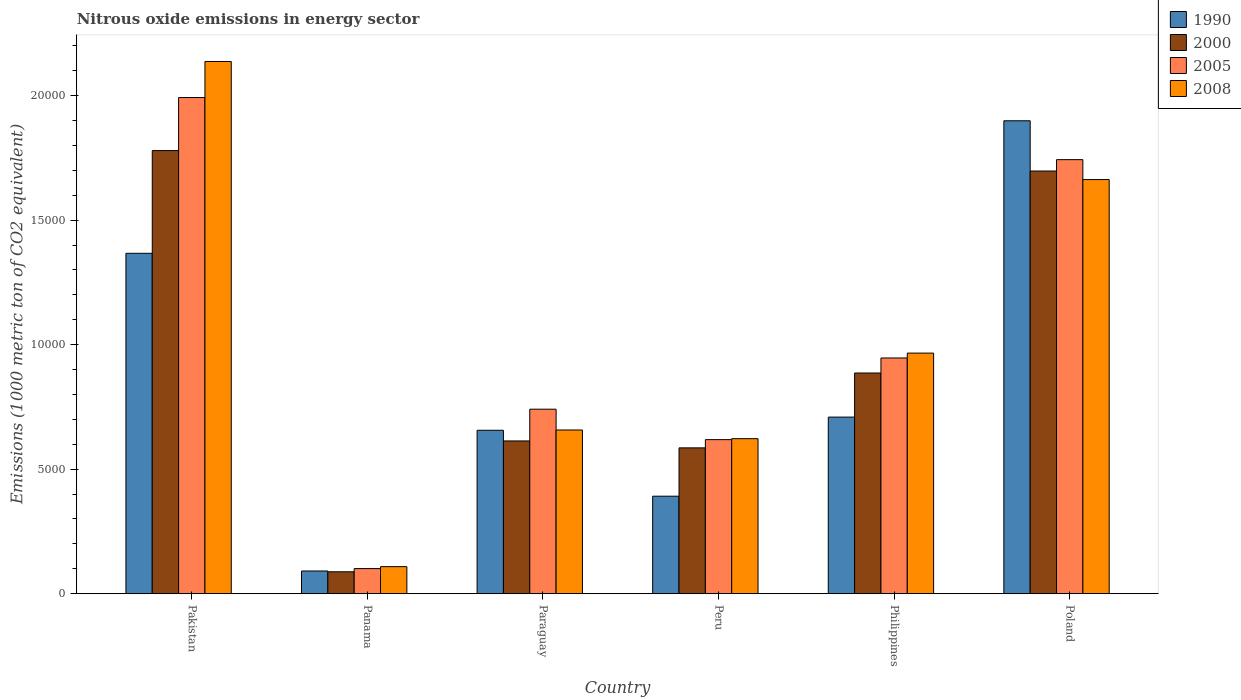How many different coloured bars are there?
Provide a short and direct response. 4. Are the number of bars per tick equal to the number of legend labels?
Your response must be concise. Yes. Are the number of bars on each tick of the X-axis equal?
Provide a succinct answer. Yes. How many bars are there on the 2nd tick from the left?
Your response must be concise. 4. What is the label of the 2nd group of bars from the left?
Offer a terse response. Panama. What is the amount of nitrous oxide emitted in 2008 in Paraguay?
Provide a short and direct response. 6573. Across all countries, what is the maximum amount of nitrous oxide emitted in 2000?
Keep it short and to the point. 1.78e+04. Across all countries, what is the minimum amount of nitrous oxide emitted in 1990?
Your answer should be very brief. 910.4. In which country was the amount of nitrous oxide emitted in 1990 minimum?
Give a very brief answer. Panama. What is the total amount of nitrous oxide emitted in 2005 in the graph?
Your response must be concise. 6.14e+04. What is the difference between the amount of nitrous oxide emitted in 2008 in Panama and that in Philippines?
Provide a succinct answer. -8575.9. What is the difference between the amount of nitrous oxide emitted in 2008 in Paraguay and the amount of nitrous oxide emitted in 2005 in Peru?
Your answer should be compact. 387.2. What is the average amount of nitrous oxide emitted in 2005 per country?
Ensure brevity in your answer.  1.02e+04. What is the difference between the amount of nitrous oxide emitted of/in 2000 and amount of nitrous oxide emitted of/in 2005 in Poland?
Make the answer very short. -457.1. What is the ratio of the amount of nitrous oxide emitted in 2000 in Pakistan to that in Paraguay?
Your answer should be very brief. 2.9. Is the amount of nitrous oxide emitted in 2008 in Peru less than that in Philippines?
Give a very brief answer. Yes. Is the difference between the amount of nitrous oxide emitted in 2000 in Peru and Philippines greater than the difference between the amount of nitrous oxide emitted in 2005 in Peru and Philippines?
Keep it short and to the point. Yes. What is the difference between the highest and the second highest amount of nitrous oxide emitted in 2005?
Offer a terse response. -1.05e+04. What is the difference between the highest and the lowest amount of nitrous oxide emitted in 2008?
Make the answer very short. 2.03e+04. Is it the case that in every country, the sum of the amount of nitrous oxide emitted in 1990 and amount of nitrous oxide emitted in 2005 is greater than the sum of amount of nitrous oxide emitted in 2000 and amount of nitrous oxide emitted in 2008?
Provide a succinct answer. No. What does the 2nd bar from the left in Panama represents?
Your response must be concise. 2000. What does the 1st bar from the right in Pakistan represents?
Offer a terse response. 2008. Is it the case that in every country, the sum of the amount of nitrous oxide emitted in 2005 and amount of nitrous oxide emitted in 2000 is greater than the amount of nitrous oxide emitted in 2008?
Your answer should be compact. Yes. What is the difference between two consecutive major ticks on the Y-axis?
Keep it short and to the point. 5000. Does the graph contain grids?
Provide a short and direct response. No. Where does the legend appear in the graph?
Your response must be concise. Top right. How many legend labels are there?
Ensure brevity in your answer.  4. How are the legend labels stacked?
Offer a very short reply. Vertical. What is the title of the graph?
Your answer should be compact. Nitrous oxide emissions in energy sector. Does "1994" appear as one of the legend labels in the graph?
Make the answer very short. No. What is the label or title of the Y-axis?
Provide a succinct answer. Emissions (1000 metric ton of CO2 equivalent). What is the Emissions (1000 metric ton of CO2 equivalent) of 1990 in Pakistan?
Give a very brief answer. 1.37e+04. What is the Emissions (1000 metric ton of CO2 equivalent) in 2000 in Pakistan?
Offer a terse response. 1.78e+04. What is the Emissions (1000 metric ton of CO2 equivalent) of 2005 in Pakistan?
Ensure brevity in your answer.  1.99e+04. What is the Emissions (1000 metric ton of CO2 equivalent) in 2008 in Pakistan?
Offer a terse response. 2.14e+04. What is the Emissions (1000 metric ton of CO2 equivalent) in 1990 in Panama?
Offer a terse response. 910.4. What is the Emissions (1000 metric ton of CO2 equivalent) of 2000 in Panama?
Provide a short and direct response. 878.4. What is the Emissions (1000 metric ton of CO2 equivalent) of 2005 in Panama?
Make the answer very short. 1006.8. What is the Emissions (1000 metric ton of CO2 equivalent) of 2008 in Panama?
Your answer should be compact. 1084.9. What is the Emissions (1000 metric ton of CO2 equivalent) in 1990 in Paraguay?
Ensure brevity in your answer.  6561.2. What is the Emissions (1000 metric ton of CO2 equivalent) of 2000 in Paraguay?
Offer a very short reply. 6132.8. What is the Emissions (1000 metric ton of CO2 equivalent) in 2005 in Paraguay?
Ensure brevity in your answer.  7407.7. What is the Emissions (1000 metric ton of CO2 equivalent) in 2008 in Paraguay?
Ensure brevity in your answer.  6573. What is the Emissions (1000 metric ton of CO2 equivalent) of 1990 in Peru?
Make the answer very short. 3914.1. What is the Emissions (1000 metric ton of CO2 equivalent) in 2000 in Peru?
Offer a terse response. 5854.9. What is the Emissions (1000 metric ton of CO2 equivalent) of 2005 in Peru?
Your answer should be very brief. 6185.8. What is the Emissions (1000 metric ton of CO2 equivalent) of 2008 in Peru?
Provide a succinct answer. 6224.5. What is the Emissions (1000 metric ton of CO2 equivalent) of 1990 in Philippines?
Your response must be concise. 7090.2. What is the Emissions (1000 metric ton of CO2 equivalent) in 2000 in Philippines?
Your answer should be very brief. 8861.1. What is the Emissions (1000 metric ton of CO2 equivalent) of 2005 in Philippines?
Give a very brief answer. 9465.1. What is the Emissions (1000 metric ton of CO2 equivalent) of 2008 in Philippines?
Offer a terse response. 9660.8. What is the Emissions (1000 metric ton of CO2 equivalent) of 1990 in Poland?
Give a very brief answer. 1.90e+04. What is the Emissions (1000 metric ton of CO2 equivalent) in 2000 in Poland?
Offer a very short reply. 1.70e+04. What is the Emissions (1000 metric ton of CO2 equivalent) in 2005 in Poland?
Your response must be concise. 1.74e+04. What is the Emissions (1000 metric ton of CO2 equivalent) of 2008 in Poland?
Provide a succinct answer. 1.66e+04. Across all countries, what is the maximum Emissions (1000 metric ton of CO2 equivalent) in 1990?
Provide a succinct answer. 1.90e+04. Across all countries, what is the maximum Emissions (1000 metric ton of CO2 equivalent) in 2000?
Offer a very short reply. 1.78e+04. Across all countries, what is the maximum Emissions (1000 metric ton of CO2 equivalent) in 2005?
Offer a very short reply. 1.99e+04. Across all countries, what is the maximum Emissions (1000 metric ton of CO2 equivalent) of 2008?
Keep it short and to the point. 2.14e+04. Across all countries, what is the minimum Emissions (1000 metric ton of CO2 equivalent) of 1990?
Give a very brief answer. 910.4. Across all countries, what is the minimum Emissions (1000 metric ton of CO2 equivalent) of 2000?
Offer a terse response. 878.4. Across all countries, what is the minimum Emissions (1000 metric ton of CO2 equivalent) of 2005?
Ensure brevity in your answer.  1006.8. Across all countries, what is the minimum Emissions (1000 metric ton of CO2 equivalent) of 2008?
Offer a very short reply. 1084.9. What is the total Emissions (1000 metric ton of CO2 equivalent) of 1990 in the graph?
Make the answer very short. 5.11e+04. What is the total Emissions (1000 metric ton of CO2 equivalent) of 2000 in the graph?
Your answer should be very brief. 5.65e+04. What is the total Emissions (1000 metric ton of CO2 equivalent) of 2005 in the graph?
Your response must be concise. 6.14e+04. What is the total Emissions (1000 metric ton of CO2 equivalent) in 2008 in the graph?
Offer a terse response. 6.15e+04. What is the difference between the Emissions (1000 metric ton of CO2 equivalent) of 1990 in Pakistan and that in Panama?
Make the answer very short. 1.28e+04. What is the difference between the Emissions (1000 metric ton of CO2 equivalent) of 2000 in Pakistan and that in Panama?
Ensure brevity in your answer.  1.69e+04. What is the difference between the Emissions (1000 metric ton of CO2 equivalent) of 2005 in Pakistan and that in Panama?
Your answer should be very brief. 1.89e+04. What is the difference between the Emissions (1000 metric ton of CO2 equivalent) in 2008 in Pakistan and that in Panama?
Give a very brief answer. 2.03e+04. What is the difference between the Emissions (1000 metric ton of CO2 equivalent) of 1990 in Pakistan and that in Paraguay?
Provide a succinct answer. 7107. What is the difference between the Emissions (1000 metric ton of CO2 equivalent) of 2000 in Pakistan and that in Paraguay?
Your response must be concise. 1.17e+04. What is the difference between the Emissions (1000 metric ton of CO2 equivalent) of 2005 in Pakistan and that in Paraguay?
Offer a terse response. 1.25e+04. What is the difference between the Emissions (1000 metric ton of CO2 equivalent) of 2008 in Pakistan and that in Paraguay?
Your answer should be compact. 1.48e+04. What is the difference between the Emissions (1000 metric ton of CO2 equivalent) in 1990 in Pakistan and that in Peru?
Offer a terse response. 9754.1. What is the difference between the Emissions (1000 metric ton of CO2 equivalent) in 2000 in Pakistan and that in Peru?
Keep it short and to the point. 1.19e+04. What is the difference between the Emissions (1000 metric ton of CO2 equivalent) in 2005 in Pakistan and that in Peru?
Keep it short and to the point. 1.37e+04. What is the difference between the Emissions (1000 metric ton of CO2 equivalent) of 2008 in Pakistan and that in Peru?
Provide a short and direct response. 1.51e+04. What is the difference between the Emissions (1000 metric ton of CO2 equivalent) of 1990 in Pakistan and that in Philippines?
Offer a terse response. 6578. What is the difference between the Emissions (1000 metric ton of CO2 equivalent) in 2000 in Pakistan and that in Philippines?
Offer a very short reply. 8932.4. What is the difference between the Emissions (1000 metric ton of CO2 equivalent) of 2005 in Pakistan and that in Philippines?
Make the answer very short. 1.05e+04. What is the difference between the Emissions (1000 metric ton of CO2 equivalent) in 2008 in Pakistan and that in Philippines?
Keep it short and to the point. 1.17e+04. What is the difference between the Emissions (1000 metric ton of CO2 equivalent) of 1990 in Pakistan and that in Poland?
Your response must be concise. -5322.5. What is the difference between the Emissions (1000 metric ton of CO2 equivalent) in 2000 in Pakistan and that in Poland?
Make the answer very short. 821. What is the difference between the Emissions (1000 metric ton of CO2 equivalent) of 2005 in Pakistan and that in Poland?
Provide a short and direct response. 2494.4. What is the difference between the Emissions (1000 metric ton of CO2 equivalent) of 2008 in Pakistan and that in Poland?
Provide a short and direct response. 4741.7. What is the difference between the Emissions (1000 metric ton of CO2 equivalent) in 1990 in Panama and that in Paraguay?
Offer a terse response. -5650.8. What is the difference between the Emissions (1000 metric ton of CO2 equivalent) of 2000 in Panama and that in Paraguay?
Give a very brief answer. -5254.4. What is the difference between the Emissions (1000 metric ton of CO2 equivalent) in 2005 in Panama and that in Paraguay?
Offer a very short reply. -6400.9. What is the difference between the Emissions (1000 metric ton of CO2 equivalent) in 2008 in Panama and that in Paraguay?
Give a very brief answer. -5488.1. What is the difference between the Emissions (1000 metric ton of CO2 equivalent) of 1990 in Panama and that in Peru?
Your answer should be very brief. -3003.7. What is the difference between the Emissions (1000 metric ton of CO2 equivalent) of 2000 in Panama and that in Peru?
Keep it short and to the point. -4976.5. What is the difference between the Emissions (1000 metric ton of CO2 equivalent) of 2005 in Panama and that in Peru?
Your answer should be very brief. -5179. What is the difference between the Emissions (1000 metric ton of CO2 equivalent) of 2008 in Panama and that in Peru?
Ensure brevity in your answer.  -5139.6. What is the difference between the Emissions (1000 metric ton of CO2 equivalent) in 1990 in Panama and that in Philippines?
Make the answer very short. -6179.8. What is the difference between the Emissions (1000 metric ton of CO2 equivalent) in 2000 in Panama and that in Philippines?
Make the answer very short. -7982.7. What is the difference between the Emissions (1000 metric ton of CO2 equivalent) in 2005 in Panama and that in Philippines?
Make the answer very short. -8458.3. What is the difference between the Emissions (1000 metric ton of CO2 equivalent) of 2008 in Panama and that in Philippines?
Offer a terse response. -8575.9. What is the difference between the Emissions (1000 metric ton of CO2 equivalent) of 1990 in Panama and that in Poland?
Your response must be concise. -1.81e+04. What is the difference between the Emissions (1000 metric ton of CO2 equivalent) of 2000 in Panama and that in Poland?
Give a very brief answer. -1.61e+04. What is the difference between the Emissions (1000 metric ton of CO2 equivalent) in 2005 in Panama and that in Poland?
Your response must be concise. -1.64e+04. What is the difference between the Emissions (1000 metric ton of CO2 equivalent) in 2008 in Panama and that in Poland?
Ensure brevity in your answer.  -1.55e+04. What is the difference between the Emissions (1000 metric ton of CO2 equivalent) of 1990 in Paraguay and that in Peru?
Make the answer very short. 2647.1. What is the difference between the Emissions (1000 metric ton of CO2 equivalent) in 2000 in Paraguay and that in Peru?
Offer a terse response. 277.9. What is the difference between the Emissions (1000 metric ton of CO2 equivalent) in 2005 in Paraguay and that in Peru?
Provide a short and direct response. 1221.9. What is the difference between the Emissions (1000 metric ton of CO2 equivalent) in 2008 in Paraguay and that in Peru?
Give a very brief answer. 348.5. What is the difference between the Emissions (1000 metric ton of CO2 equivalent) in 1990 in Paraguay and that in Philippines?
Your answer should be compact. -529. What is the difference between the Emissions (1000 metric ton of CO2 equivalent) in 2000 in Paraguay and that in Philippines?
Your answer should be very brief. -2728.3. What is the difference between the Emissions (1000 metric ton of CO2 equivalent) of 2005 in Paraguay and that in Philippines?
Provide a succinct answer. -2057.4. What is the difference between the Emissions (1000 metric ton of CO2 equivalent) in 2008 in Paraguay and that in Philippines?
Provide a short and direct response. -3087.8. What is the difference between the Emissions (1000 metric ton of CO2 equivalent) in 1990 in Paraguay and that in Poland?
Offer a terse response. -1.24e+04. What is the difference between the Emissions (1000 metric ton of CO2 equivalent) of 2000 in Paraguay and that in Poland?
Provide a short and direct response. -1.08e+04. What is the difference between the Emissions (1000 metric ton of CO2 equivalent) of 2005 in Paraguay and that in Poland?
Your answer should be compact. -1.00e+04. What is the difference between the Emissions (1000 metric ton of CO2 equivalent) of 2008 in Paraguay and that in Poland?
Your response must be concise. -1.01e+04. What is the difference between the Emissions (1000 metric ton of CO2 equivalent) of 1990 in Peru and that in Philippines?
Your answer should be very brief. -3176.1. What is the difference between the Emissions (1000 metric ton of CO2 equivalent) in 2000 in Peru and that in Philippines?
Offer a terse response. -3006.2. What is the difference between the Emissions (1000 metric ton of CO2 equivalent) in 2005 in Peru and that in Philippines?
Ensure brevity in your answer.  -3279.3. What is the difference between the Emissions (1000 metric ton of CO2 equivalent) of 2008 in Peru and that in Philippines?
Offer a terse response. -3436.3. What is the difference between the Emissions (1000 metric ton of CO2 equivalent) in 1990 in Peru and that in Poland?
Your answer should be very brief. -1.51e+04. What is the difference between the Emissions (1000 metric ton of CO2 equivalent) of 2000 in Peru and that in Poland?
Your answer should be compact. -1.11e+04. What is the difference between the Emissions (1000 metric ton of CO2 equivalent) in 2005 in Peru and that in Poland?
Your answer should be compact. -1.12e+04. What is the difference between the Emissions (1000 metric ton of CO2 equivalent) of 2008 in Peru and that in Poland?
Offer a very short reply. -1.04e+04. What is the difference between the Emissions (1000 metric ton of CO2 equivalent) in 1990 in Philippines and that in Poland?
Your answer should be very brief. -1.19e+04. What is the difference between the Emissions (1000 metric ton of CO2 equivalent) of 2000 in Philippines and that in Poland?
Your answer should be compact. -8111.4. What is the difference between the Emissions (1000 metric ton of CO2 equivalent) in 2005 in Philippines and that in Poland?
Your response must be concise. -7964.5. What is the difference between the Emissions (1000 metric ton of CO2 equivalent) of 2008 in Philippines and that in Poland?
Make the answer very short. -6969.3. What is the difference between the Emissions (1000 metric ton of CO2 equivalent) of 1990 in Pakistan and the Emissions (1000 metric ton of CO2 equivalent) of 2000 in Panama?
Keep it short and to the point. 1.28e+04. What is the difference between the Emissions (1000 metric ton of CO2 equivalent) in 1990 in Pakistan and the Emissions (1000 metric ton of CO2 equivalent) in 2005 in Panama?
Offer a terse response. 1.27e+04. What is the difference between the Emissions (1000 metric ton of CO2 equivalent) of 1990 in Pakistan and the Emissions (1000 metric ton of CO2 equivalent) of 2008 in Panama?
Your answer should be very brief. 1.26e+04. What is the difference between the Emissions (1000 metric ton of CO2 equivalent) in 2000 in Pakistan and the Emissions (1000 metric ton of CO2 equivalent) in 2005 in Panama?
Your answer should be very brief. 1.68e+04. What is the difference between the Emissions (1000 metric ton of CO2 equivalent) in 2000 in Pakistan and the Emissions (1000 metric ton of CO2 equivalent) in 2008 in Panama?
Ensure brevity in your answer.  1.67e+04. What is the difference between the Emissions (1000 metric ton of CO2 equivalent) in 2005 in Pakistan and the Emissions (1000 metric ton of CO2 equivalent) in 2008 in Panama?
Offer a very short reply. 1.88e+04. What is the difference between the Emissions (1000 metric ton of CO2 equivalent) in 1990 in Pakistan and the Emissions (1000 metric ton of CO2 equivalent) in 2000 in Paraguay?
Offer a very short reply. 7535.4. What is the difference between the Emissions (1000 metric ton of CO2 equivalent) in 1990 in Pakistan and the Emissions (1000 metric ton of CO2 equivalent) in 2005 in Paraguay?
Provide a short and direct response. 6260.5. What is the difference between the Emissions (1000 metric ton of CO2 equivalent) of 1990 in Pakistan and the Emissions (1000 metric ton of CO2 equivalent) of 2008 in Paraguay?
Offer a terse response. 7095.2. What is the difference between the Emissions (1000 metric ton of CO2 equivalent) in 2000 in Pakistan and the Emissions (1000 metric ton of CO2 equivalent) in 2005 in Paraguay?
Your answer should be compact. 1.04e+04. What is the difference between the Emissions (1000 metric ton of CO2 equivalent) of 2000 in Pakistan and the Emissions (1000 metric ton of CO2 equivalent) of 2008 in Paraguay?
Provide a short and direct response. 1.12e+04. What is the difference between the Emissions (1000 metric ton of CO2 equivalent) in 2005 in Pakistan and the Emissions (1000 metric ton of CO2 equivalent) in 2008 in Paraguay?
Give a very brief answer. 1.34e+04. What is the difference between the Emissions (1000 metric ton of CO2 equivalent) of 1990 in Pakistan and the Emissions (1000 metric ton of CO2 equivalent) of 2000 in Peru?
Provide a short and direct response. 7813.3. What is the difference between the Emissions (1000 metric ton of CO2 equivalent) in 1990 in Pakistan and the Emissions (1000 metric ton of CO2 equivalent) in 2005 in Peru?
Provide a succinct answer. 7482.4. What is the difference between the Emissions (1000 metric ton of CO2 equivalent) in 1990 in Pakistan and the Emissions (1000 metric ton of CO2 equivalent) in 2008 in Peru?
Provide a succinct answer. 7443.7. What is the difference between the Emissions (1000 metric ton of CO2 equivalent) of 2000 in Pakistan and the Emissions (1000 metric ton of CO2 equivalent) of 2005 in Peru?
Your answer should be very brief. 1.16e+04. What is the difference between the Emissions (1000 metric ton of CO2 equivalent) of 2000 in Pakistan and the Emissions (1000 metric ton of CO2 equivalent) of 2008 in Peru?
Make the answer very short. 1.16e+04. What is the difference between the Emissions (1000 metric ton of CO2 equivalent) in 2005 in Pakistan and the Emissions (1000 metric ton of CO2 equivalent) in 2008 in Peru?
Give a very brief answer. 1.37e+04. What is the difference between the Emissions (1000 metric ton of CO2 equivalent) in 1990 in Pakistan and the Emissions (1000 metric ton of CO2 equivalent) in 2000 in Philippines?
Keep it short and to the point. 4807.1. What is the difference between the Emissions (1000 metric ton of CO2 equivalent) in 1990 in Pakistan and the Emissions (1000 metric ton of CO2 equivalent) in 2005 in Philippines?
Your response must be concise. 4203.1. What is the difference between the Emissions (1000 metric ton of CO2 equivalent) in 1990 in Pakistan and the Emissions (1000 metric ton of CO2 equivalent) in 2008 in Philippines?
Your answer should be very brief. 4007.4. What is the difference between the Emissions (1000 metric ton of CO2 equivalent) of 2000 in Pakistan and the Emissions (1000 metric ton of CO2 equivalent) of 2005 in Philippines?
Make the answer very short. 8328.4. What is the difference between the Emissions (1000 metric ton of CO2 equivalent) in 2000 in Pakistan and the Emissions (1000 metric ton of CO2 equivalent) in 2008 in Philippines?
Provide a short and direct response. 8132.7. What is the difference between the Emissions (1000 metric ton of CO2 equivalent) of 2005 in Pakistan and the Emissions (1000 metric ton of CO2 equivalent) of 2008 in Philippines?
Provide a succinct answer. 1.03e+04. What is the difference between the Emissions (1000 metric ton of CO2 equivalent) in 1990 in Pakistan and the Emissions (1000 metric ton of CO2 equivalent) in 2000 in Poland?
Provide a succinct answer. -3304.3. What is the difference between the Emissions (1000 metric ton of CO2 equivalent) in 1990 in Pakistan and the Emissions (1000 metric ton of CO2 equivalent) in 2005 in Poland?
Make the answer very short. -3761.4. What is the difference between the Emissions (1000 metric ton of CO2 equivalent) in 1990 in Pakistan and the Emissions (1000 metric ton of CO2 equivalent) in 2008 in Poland?
Your answer should be very brief. -2961.9. What is the difference between the Emissions (1000 metric ton of CO2 equivalent) in 2000 in Pakistan and the Emissions (1000 metric ton of CO2 equivalent) in 2005 in Poland?
Your response must be concise. 363.9. What is the difference between the Emissions (1000 metric ton of CO2 equivalent) of 2000 in Pakistan and the Emissions (1000 metric ton of CO2 equivalent) of 2008 in Poland?
Make the answer very short. 1163.4. What is the difference between the Emissions (1000 metric ton of CO2 equivalent) of 2005 in Pakistan and the Emissions (1000 metric ton of CO2 equivalent) of 2008 in Poland?
Ensure brevity in your answer.  3293.9. What is the difference between the Emissions (1000 metric ton of CO2 equivalent) in 1990 in Panama and the Emissions (1000 metric ton of CO2 equivalent) in 2000 in Paraguay?
Your answer should be very brief. -5222.4. What is the difference between the Emissions (1000 metric ton of CO2 equivalent) of 1990 in Panama and the Emissions (1000 metric ton of CO2 equivalent) of 2005 in Paraguay?
Your answer should be compact. -6497.3. What is the difference between the Emissions (1000 metric ton of CO2 equivalent) in 1990 in Panama and the Emissions (1000 metric ton of CO2 equivalent) in 2008 in Paraguay?
Offer a very short reply. -5662.6. What is the difference between the Emissions (1000 metric ton of CO2 equivalent) in 2000 in Panama and the Emissions (1000 metric ton of CO2 equivalent) in 2005 in Paraguay?
Your response must be concise. -6529.3. What is the difference between the Emissions (1000 metric ton of CO2 equivalent) of 2000 in Panama and the Emissions (1000 metric ton of CO2 equivalent) of 2008 in Paraguay?
Offer a very short reply. -5694.6. What is the difference between the Emissions (1000 metric ton of CO2 equivalent) of 2005 in Panama and the Emissions (1000 metric ton of CO2 equivalent) of 2008 in Paraguay?
Your answer should be very brief. -5566.2. What is the difference between the Emissions (1000 metric ton of CO2 equivalent) of 1990 in Panama and the Emissions (1000 metric ton of CO2 equivalent) of 2000 in Peru?
Provide a succinct answer. -4944.5. What is the difference between the Emissions (1000 metric ton of CO2 equivalent) in 1990 in Panama and the Emissions (1000 metric ton of CO2 equivalent) in 2005 in Peru?
Ensure brevity in your answer.  -5275.4. What is the difference between the Emissions (1000 metric ton of CO2 equivalent) of 1990 in Panama and the Emissions (1000 metric ton of CO2 equivalent) of 2008 in Peru?
Provide a succinct answer. -5314.1. What is the difference between the Emissions (1000 metric ton of CO2 equivalent) of 2000 in Panama and the Emissions (1000 metric ton of CO2 equivalent) of 2005 in Peru?
Your response must be concise. -5307.4. What is the difference between the Emissions (1000 metric ton of CO2 equivalent) of 2000 in Panama and the Emissions (1000 metric ton of CO2 equivalent) of 2008 in Peru?
Provide a succinct answer. -5346.1. What is the difference between the Emissions (1000 metric ton of CO2 equivalent) of 2005 in Panama and the Emissions (1000 metric ton of CO2 equivalent) of 2008 in Peru?
Your answer should be very brief. -5217.7. What is the difference between the Emissions (1000 metric ton of CO2 equivalent) of 1990 in Panama and the Emissions (1000 metric ton of CO2 equivalent) of 2000 in Philippines?
Give a very brief answer. -7950.7. What is the difference between the Emissions (1000 metric ton of CO2 equivalent) in 1990 in Panama and the Emissions (1000 metric ton of CO2 equivalent) in 2005 in Philippines?
Provide a short and direct response. -8554.7. What is the difference between the Emissions (1000 metric ton of CO2 equivalent) in 1990 in Panama and the Emissions (1000 metric ton of CO2 equivalent) in 2008 in Philippines?
Make the answer very short. -8750.4. What is the difference between the Emissions (1000 metric ton of CO2 equivalent) in 2000 in Panama and the Emissions (1000 metric ton of CO2 equivalent) in 2005 in Philippines?
Your answer should be very brief. -8586.7. What is the difference between the Emissions (1000 metric ton of CO2 equivalent) of 2000 in Panama and the Emissions (1000 metric ton of CO2 equivalent) of 2008 in Philippines?
Make the answer very short. -8782.4. What is the difference between the Emissions (1000 metric ton of CO2 equivalent) of 2005 in Panama and the Emissions (1000 metric ton of CO2 equivalent) of 2008 in Philippines?
Provide a short and direct response. -8654. What is the difference between the Emissions (1000 metric ton of CO2 equivalent) of 1990 in Panama and the Emissions (1000 metric ton of CO2 equivalent) of 2000 in Poland?
Provide a short and direct response. -1.61e+04. What is the difference between the Emissions (1000 metric ton of CO2 equivalent) in 1990 in Panama and the Emissions (1000 metric ton of CO2 equivalent) in 2005 in Poland?
Your answer should be compact. -1.65e+04. What is the difference between the Emissions (1000 metric ton of CO2 equivalent) in 1990 in Panama and the Emissions (1000 metric ton of CO2 equivalent) in 2008 in Poland?
Give a very brief answer. -1.57e+04. What is the difference between the Emissions (1000 metric ton of CO2 equivalent) in 2000 in Panama and the Emissions (1000 metric ton of CO2 equivalent) in 2005 in Poland?
Provide a succinct answer. -1.66e+04. What is the difference between the Emissions (1000 metric ton of CO2 equivalent) in 2000 in Panama and the Emissions (1000 metric ton of CO2 equivalent) in 2008 in Poland?
Provide a succinct answer. -1.58e+04. What is the difference between the Emissions (1000 metric ton of CO2 equivalent) in 2005 in Panama and the Emissions (1000 metric ton of CO2 equivalent) in 2008 in Poland?
Your answer should be compact. -1.56e+04. What is the difference between the Emissions (1000 metric ton of CO2 equivalent) of 1990 in Paraguay and the Emissions (1000 metric ton of CO2 equivalent) of 2000 in Peru?
Keep it short and to the point. 706.3. What is the difference between the Emissions (1000 metric ton of CO2 equivalent) in 1990 in Paraguay and the Emissions (1000 metric ton of CO2 equivalent) in 2005 in Peru?
Provide a succinct answer. 375.4. What is the difference between the Emissions (1000 metric ton of CO2 equivalent) of 1990 in Paraguay and the Emissions (1000 metric ton of CO2 equivalent) of 2008 in Peru?
Ensure brevity in your answer.  336.7. What is the difference between the Emissions (1000 metric ton of CO2 equivalent) in 2000 in Paraguay and the Emissions (1000 metric ton of CO2 equivalent) in 2005 in Peru?
Make the answer very short. -53. What is the difference between the Emissions (1000 metric ton of CO2 equivalent) of 2000 in Paraguay and the Emissions (1000 metric ton of CO2 equivalent) of 2008 in Peru?
Offer a very short reply. -91.7. What is the difference between the Emissions (1000 metric ton of CO2 equivalent) of 2005 in Paraguay and the Emissions (1000 metric ton of CO2 equivalent) of 2008 in Peru?
Your answer should be compact. 1183.2. What is the difference between the Emissions (1000 metric ton of CO2 equivalent) of 1990 in Paraguay and the Emissions (1000 metric ton of CO2 equivalent) of 2000 in Philippines?
Provide a succinct answer. -2299.9. What is the difference between the Emissions (1000 metric ton of CO2 equivalent) of 1990 in Paraguay and the Emissions (1000 metric ton of CO2 equivalent) of 2005 in Philippines?
Provide a succinct answer. -2903.9. What is the difference between the Emissions (1000 metric ton of CO2 equivalent) of 1990 in Paraguay and the Emissions (1000 metric ton of CO2 equivalent) of 2008 in Philippines?
Ensure brevity in your answer.  -3099.6. What is the difference between the Emissions (1000 metric ton of CO2 equivalent) in 2000 in Paraguay and the Emissions (1000 metric ton of CO2 equivalent) in 2005 in Philippines?
Keep it short and to the point. -3332.3. What is the difference between the Emissions (1000 metric ton of CO2 equivalent) in 2000 in Paraguay and the Emissions (1000 metric ton of CO2 equivalent) in 2008 in Philippines?
Offer a very short reply. -3528. What is the difference between the Emissions (1000 metric ton of CO2 equivalent) of 2005 in Paraguay and the Emissions (1000 metric ton of CO2 equivalent) of 2008 in Philippines?
Give a very brief answer. -2253.1. What is the difference between the Emissions (1000 metric ton of CO2 equivalent) in 1990 in Paraguay and the Emissions (1000 metric ton of CO2 equivalent) in 2000 in Poland?
Offer a terse response. -1.04e+04. What is the difference between the Emissions (1000 metric ton of CO2 equivalent) in 1990 in Paraguay and the Emissions (1000 metric ton of CO2 equivalent) in 2005 in Poland?
Offer a very short reply. -1.09e+04. What is the difference between the Emissions (1000 metric ton of CO2 equivalent) in 1990 in Paraguay and the Emissions (1000 metric ton of CO2 equivalent) in 2008 in Poland?
Give a very brief answer. -1.01e+04. What is the difference between the Emissions (1000 metric ton of CO2 equivalent) in 2000 in Paraguay and the Emissions (1000 metric ton of CO2 equivalent) in 2005 in Poland?
Your answer should be compact. -1.13e+04. What is the difference between the Emissions (1000 metric ton of CO2 equivalent) in 2000 in Paraguay and the Emissions (1000 metric ton of CO2 equivalent) in 2008 in Poland?
Keep it short and to the point. -1.05e+04. What is the difference between the Emissions (1000 metric ton of CO2 equivalent) of 2005 in Paraguay and the Emissions (1000 metric ton of CO2 equivalent) of 2008 in Poland?
Offer a terse response. -9222.4. What is the difference between the Emissions (1000 metric ton of CO2 equivalent) in 1990 in Peru and the Emissions (1000 metric ton of CO2 equivalent) in 2000 in Philippines?
Your answer should be compact. -4947. What is the difference between the Emissions (1000 metric ton of CO2 equivalent) of 1990 in Peru and the Emissions (1000 metric ton of CO2 equivalent) of 2005 in Philippines?
Make the answer very short. -5551. What is the difference between the Emissions (1000 metric ton of CO2 equivalent) of 1990 in Peru and the Emissions (1000 metric ton of CO2 equivalent) of 2008 in Philippines?
Give a very brief answer. -5746.7. What is the difference between the Emissions (1000 metric ton of CO2 equivalent) in 2000 in Peru and the Emissions (1000 metric ton of CO2 equivalent) in 2005 in Philippines?
Offer a terse response. -3610.2. What is the difference between the Emissions (1000 metric ton of CO2 equivalent) of 2000 in Peru and the Emissions (1000 metric ton of CO2 equivalent) of 2008 in Philippines?
Give a very brief answer. -3805.9. What is the difference between the Emissions (1000 metric ton of CO2 equivalent) in 2005 in Peru and the Emissions (1000 metric ton of CO2 equivalent) in 2008 in Philippines?
Your answer should be compact. -3475. What is the difference between the Emissions (1000 metric ton of CO2 equivalent) in 1990 in Peru and the Emissions (1000 metric ton of CO2 equivalent) in 2000 in Poland?
Your response must be concise. -1.31e+04. What is the difference between the Emissions (1000 metric ton of CO2 equivalent) of 1990 in Peru and the Emissions (1000 metric ton of CO2 equivalent) of 2005 in Poland?
Your answer should be compact. -1.35e+04. What is the difference between the Emissions (1000 metric ton of CO2 equivalent) in 1990 in Peru and the Emissions (1000 metric ton of CO2 equivalent) in 2008 in Poland?
Keep it short and to the point. -1.27e+04. What is the difference between the Emissions (1000 metric ton of CO2 equivalent) of 2000 in Peru and the Emissions (1000 metric ton of CO2 equivalent) of 2005 in Poland?
Your answer should be very brief. -1.16e+04. What is the difference between the Emissions (1000 metric ton of CO2 equivalent) of 2000 in Peru and the Emissions (1000 metric ton of CO2 equivalent) of 2008 in Poland?
Ensure brevity in your answer.  -1.08e+04. What is the difference between the Emissions (1000 metric ton of CO2 equivalent) in 2005 in Peru and the Emissions (1000 metric ton of CO2 equivalent) in 2008 in Poland?
Provide a short and direct response. -1.04e+04. What is the difference between the Emissions (1000 metric ton of CO2 equivalent) in 1990 in Philippines and the Emissions (1000 metric ton of CO2 equivalent) in 2000 in Poland?
Offer a very short reply. -9882.3. What is the difference between the Emissions (1000 metric ton of CO2 equivalent) in 1990 in Philippines and the Emissions (1000 metric ton of CO2 equivalent) in 2005 in Poland?
Offer a very short reply. -1.03e+04. What is the difference between the Emissions (1000 metric ton of CO2 equivalent) in 1990 in Philippines and the Emissions (1000 metric ton of CO2 equivalent) in 2008 in Poland?
Offer a terse response. -9539.9. What is the difference between the Emissions (1000 metric ton of CO2 equivalent) of 2000 in Philippines and the Emissions (1000 metric ton of CO2 equivalent) of 2005 in Poland?
Keep it short and to the point. -8568.5. What is the difference between the Emissions (1000 metric ton of CO2 equivalent) in 2000 in Philippines and the Emissions (1000 metric ton of CO2 equivalent) in 2008 in Poland?
Make the answer very short. -7769. What is the difference between the Emissions (1000 metric ton of CO2 equivalent) of 2005 in Philippines and the Emissions (1000 metric ton of CO2 equivalent) of 2008 in Poland?
Make the answer very short. -7165. What is the average Emissions (1000 metric ton of CO2 equivalent) of 1990 per country?
Offer a terse response. 8522.47. What is the average Emissions (1000 metric ton of CO2 equivalent) in 2000 per country?
Make the answer very short. 9415.53. What is the average Emissions (1000 metric ton of CO2 equivalent) of 2005 per country?
Offer a terse response. 1.02e+04. What is the average Emissions (1000 metric ton of CO2 equivalent) of 2008 per country?
Provide a succinct answer. 1.03e+04. What is the difference between the Emissions (1000 metric ton of CO2 equivalent) of 1990 and Emissions (1000 metric ton of CO2 equivalent) of 2000 in Pakistan?
Offer a very short reply. -4125.3. What is the difference between the Emissions (1000 metric ton of CO2 equivalent) of 1990 and Emissions (1000 metric ton of CO2 equivalent) of 2005 in Pakistan?
Offer a very short reply. -6255.8. What is the difference between the Emissions (1000 metric ton of CO2 equivalent) in 1990 and Emissions (1000 metric ton of CO2 equivalent) in 2008 in Pakistan?
Make the answer very short. -7703.6. What is the difference between the Emissions (1000 metric ton of CO2 equivalent) of 2000 and Emissions (1000 metric ton of CO2 equivalent) of 2005 in Pakistan?
Ensure brevity in your answer.  -2130.5. What is the difference between the Emissions (1000 metric ton of CO2 equivalent) of 2000 and Emissions (1000 metric ton of CO2 equivalent) of 2008 in Pakistan?
Give a very brief answer. -3578.3. What is the difference between the Emissions (1000 metric ton of CO2 equivalent) in 2005 and Emissions (1000 metric ton of CO2 equivalent) in 2008 in Pakistan?
Give a very brief answer. -1447.8. What is the difference between the Emissions (1000 metric ton of CO2 equivalent) in 1990 and Emissions (1000 metric ton of CO2 equivalent) in 2000 in Panama?
Your answer should be very brief. 32. What is the difference between the Emissions (1000 metric ton of CO2 equivalent) in 1990 and Emissions (1000 metric ton of CO2 equivalent) in 2005 in Panama?
Make the answer very short. -96.4. What is the difference between the Emissions (1000 metric ton of CO2 equivalent) in 1990 and Emissions (1000 metric ton of CO2 equivalent) in 2008 in Panama?
Your answer should be compact. -174.5. What is the difference between the Emissions (1000 metric ton of CO2 equivalent) in 2000 and Emissions (1000 metric ton of CO2 equivalent) in 2005 in Panama?
Your answer should be compact. -128.4. What is the difference between the Emissions (1000 metric ton of CO2 equivalent) of 2000 and Emissions (1000 metric ton of CO2 equivalent) of 2008 in Panama?
Offer a terse response. -206.5. What is the difference between the Emissions (1000 metric ton of CO2 equivalent) in 2005 and Emissions (1000 metric ton of CO2 equivalent) in 2008 in Panama?
Your response must be concise. -78.1. What is the difference between the Emissions (1000 metric ton of CO2 equivalent) in 1990 and Emissions (1000 metric ton of CO2 equivalent) in 2000 in Paraguay?
Keep it short and to the point. 428.4. What is the difference between the Emissions (1000 metric ton of CO2 equivalent) of 1990 and Emissions (1000 metric ton of CO2 equivalent) of 2005 in Paraguay?
Provide a short and direct response. -846.5. What is the difference between the Emissions (1000 metric ton of CO2 equivalent) of 2000 and Emissions (1000 metric ton of CO2 equivalent) of 2005 in Paraguay?
Offer a terse response. -1274.9. What is the difference between the Emissions (1000 metric ton of CO2 equivalent) in 2000 and Emissions (1000 metric ton of CO2 equivalent) in 2008 in Paraguay?
Offer a very short reply. -440.2. What is the difference between the Emissions (1000 metric ton of CO2 equivalent) in 2005 and Emissions (1000 metric ton of CO2 equivalent) in 2008 in Paraguay?
Your response must be concise. 834.7. What is the difference between the Emissions (1000 metric ton of CO2 equivalent) in 1990 and Emissions (1000 metric ton of CO2 equivalent) in 2000 in Peru?
Provide a succinct answer. -1940.8. What is the difference between the Emissions (1000 metric ton of CO2 equivalent) of 1990 and Emissions (1000 metric ton of CO2 equivalent) of 2005 in Peru?
Your answer should be very brief. -2271.7. What is the difference between the Emissions (1000 metric ton of CO2 equivalent) in 1990 and Emissions (1000 metric ton of CO2 equivalent) in 2008 in Peru?
Make the answer very short. -2310.4. What is the difference between the Emissions (1000 metric ton of CO2 equivalent) in 2000 and Emissions (1000 metric ton of CO2 equivalent) in 2005 in Peru?
Offer a terse response. -330.9. What is the difference between the Emissions (1000 metric ton of CO2 equivalent) of 2000 and Emissions (1000 metric ton of CO2 equivalent) of 2008 in Peru?
Ensure brevity in your answer.  -369.6. What is the difference between the Emissions (1000 metric ton of CO2 equivalent) of 2005 and Emissions (1000 metric ton of CO2 equivalent) of 2008 in Peru?
Provide a short and direct response. -38.7. What is the difference between the Emissions (1000 metric ton of CO2 equivalent) of 1990 and Emissions (1000 metric ton of CO2 equivalent) of 2000 in Philippines?
Your answer should be very brief. -1770.9. What is the difference between the Emissions (1000 metric ton of CO2 equivalent) of 1990 and Emissions (1000 metric ton of CO2 equivalent) of 2005 in Philippines?
Your answer should be compact. -2374.9. What is the difference between the Emissions (1000 metric ton of CO2 equivalent) of 1990 and Emissions (1000 metric ton of CO2 equivalent) of 2008 in Philippines?
Your answer should be very brief. -2570.6. What is the difference between the Emissions (1000 metric ton of CO2 equivalent) of 2000 and Emissions (1000 metric ton of CO2 equivalent) of 2005 in Philippines?
Your answer should be compact. -604. What is the difference between the Emissions (1000 metric ton of CO2 equivalent) in 2000 and Emissions (1000 metric ton of CO2 equivalent) in 2008 in Philippines?
Give a very brief answer. -799.7. What is the difference between the Emissions (1000 metric ton of CO2 equivalent) of 2005 and Emissions (1000 metric ton of CO2 equivalent) of 2008 in Philippines?
Keep it short and to the point. -195.7. What is the difference between the Emissions (1000 metric ton of CO2 equivalent) of 1990 and Emissions (1000 metric ton of CO2 equivalent) of 2000 in Poland?
Make the answer very short. 2018.2. What is the difference between the Emissions (1000 metric ton of CO2 equivalent) in 1990 and Emissions (1000 metric ton of CO2 equivalent) in 2005 in Poland?
Offer a very short reply. 1561.1. What is the difference between the Emissions (1000 metric ton of CO2 equivalent) in 1990 and Emissions (1000 metric ton of CO2 equivalent) in 2008 in Poland?
Your answer should be compact. 2360.6. What is the difference between the Emissions (1000 metric ton of CO2 equivalent) in 2000 and Emissions (1000 metric ton of CO2 equivalent) in 2005 in Poland?
Offer a terse response. -457.1. What is the difference between the Emissions (1000 metric ton of CO2 equivalent) of 2000 and Emissions (1000 metric ton of CO2 equivalent) of 2008 in Poland?
Give a very brief answer. 342.4. What is the difference between the Emissions (1000 metric ton of CO2 equivalent) in 2005 and Emissions (1000 metric ton of CO2 equivalent) in 2008 in Poland?
Ensure brevity in your answer.  799.5. What is the ratio of the Emissions (1000 metric ton of CO2 equivalent) of 1990 in Pakistan to that in Panama?
Provide a succinct answer. 15.01. What is the ratio of the Emissions (1000 metric ton of CO2 equivalent) in 2000 in Pakistan to that in Panama?
Offer a terse response. 20.26. What is the ratio of the Emissions (1000 metric ton of CO2 equivalent) in 2005 in Pakistan to that in Panama?
Offer a very short reply. 19.79. What is the ratio of the Emissions (1000 metric ton of CO2 equivalent) in 2008 in Pakistan to that in Panama?
Make the answer very short. 19.7. What is the ratio of the Emissions (1000 metric ton of CO2 equivalent) in 1990 in Pakistan to that in Paraguay?
Your answer should be compact. 2.08. What is the ratio of the Emissions (1000 metric ton of CO2 equivalent) in 2000 in Pakistan to that in Paraguay?
Make the answer very short. 2.9. What is the ratio of the Emissions (1000 metric ton of CO2 equivalent) in 2005 in Pakistan to that in Paraguay?
Make the answer very short. 2.69. What is the ratio of the Emissions (1000 metric ton of CO2 equivalent) in 2008 in Pakistan to that in Paraguay?
Provide a short and direct response. 3.25. What is the ratio of the Emissions (1000 metric ton of CO2 equivalent) of 1990 in Pakistan to that in Peru?
Provide a short and direct response. 3.49. What is the ratio of the Emissions (1000 metric ton of CO2 equivalent) of 2000 in Pakistan to that in Peru?
Offer a terse response. 3.04. What is the ratio of the Emissions (1000 metric ton of CO2 equivalent) of 2005 in Pakistan to that in Peru?
Offer a very short reply. 3.22. What is the ratio of the Emissions (1000 metric ton of CO2 equivalent) of 2008 in Pakistan to that in Peru?
Provide a short and direct response. 3.43. What is the ratio of the Emissions (1000 metric ton of CO2 equivalent) of 1990 in Pakistan to that in Philippines?
Offer a very short reply. 1.93. What is the ratio of the Emissions (1000 metric ton of CO2 equivalent) of 2000 in Pakistan to that in Philippines?
Give a very brief answer. 2.01. What is the ratio of the Emissions (1000 metric ton of CO2 equivalent) in 2005 in Pakistan to that in Philippines?
Your answer should be very brief. 2.1. What is the ratio of the Emissions (1000 metric ton of CO2 equivalent) in 2008 in Pakistan to that in Philippines?
Provide a succinct answer. 2.21. What is the ratio of the Emissions (1000 metric ton of CO2 equivalent) in 1990 in Pakistan to that in Poland?
Provide a succinct answer. 0.72. What is the ratio of the Emissions (1000 metric ton of CO2 equivalent) in 2000 in Pakistan to that in Poland?
Offer a very short reply. 1.05. What is the ratio of the Emissions (1000 metric ton of CO2 equivalent) of 2005 in Pakistan to that in Poland?
Your response must be concise. 1.14. What is the ratio of the Emissions (1000 metric ton of CO2 equivalent) in 2008 in Pakistan to that in Poland?
Keep it short and to the point. 1.29. What is the ratio of the Emissions (1000 metric ton of CO2 equivalent) of 1990 in Panama to that in Paraguay?
Give a very brief answer. 0.14. What is the ratio of the Emissions (1000 metric ton of CO2 equivalent) in 2000 in Panama to that in Paraguay?
Keep it short and to the point. 0.14. What is the ratio of the Emissions (1000 metric ton of CO2 equivalent) in 2005 in Panama to that in Paraguay?
Keep it short and to the point. 0.14. What is the ratio of the Emissions (1000 metric ton of CO2 equivalent) in 2008 in Panama to that in Paraguay?
Keep it short and to the point. 0.17. What is the ratio of the Emissions (1000 metric ton of CO2 equivalent) in 1990 in Panama to that in Peru?
Your answer should be very brief. 0.23. What is the ratio of the Emissions (1000 metric ton of CO2 equivalent) in 2000 in Panama to that in Peru?
Your answer should be very brief. 0.15. What is the ratio of the Emissions (1000 metric ton of CO2 equivalent) in 2005 in Panama to that in Peru?
Your answer should be compact. 0.16. What is the ratio of the Emissions (1000 metric ton of CO2 equivalent) of 2008 in Panama to that in Peru?
Your answer should be compact. 0.17. What is the ratio of the Emissions (1000 metric ton of CO2 equivalent) in 1990 in Panama to that in Philippines?
Give a very brief answer. 0.13. What is the ratio of the Emissions (1000 metric ton of CO2 equivalent) of 2000 in Panama to that in Philippines?
Keep it short and to the point. 0.1. What is the ratio of the Emissions (1000 metric ton of CO2 equivalent) of 2005 in Panama to that in Philippines?
Provide a short and direct response. 0.11. What is the ratio of the Emissions (1000 metric ton of CO2 equivalent) in 2008 in Panama to that in Philippines?
Keep it short and to the point. 0.11. What is the ratio of the Emissions (1000 metric ton of CO2 equivalent) in 1990 in Panama to that in Poland?
Make the answer very short. 0.05. What is the ratio of the Emissions (1000 metric ton of CO2 equivalent) of 2000 in Panama to that in Poland?
Ensure brevity in your answer.  0.05. What is the ratio of the Emissions (1000 metric ton of CO2 equivalent) of 2005 in Panama to that in Poland?
Your answer should be compact. 0.06. What is the ratio of the Emissions (1000 metric ton of CO2 equivalent) in 2008 in Panama to that in Poland?
Give a very brief answer. 0.07. What is the ratio of the Emissions (1000 metric ton of CO2 equivalent) in 1990 in Paraguay to that in Peru?
Provide a succinct answer. 1.68. What is the ratio of the Emissions (1000 metric ton of CO2 equivalent) of 2000 in Paraguay to that in Peru?
Provide a short and direct response. 1.05. What is the ratio of the Emissions (1000 metric ton of CO2 equivalent) in 2005 in Paraguay to that in Peru?
Your answer should be compact. 1.2. What is the ratio of the Emissions (1000 metric ton of CO2 equivalent) in 2008 in Paraguay to that in Peru?
Keep it short and to the point. 1.06. What is the ratio of the Emissions (1000 metric ton of CO2 equivalent) of 1990 in Paraguay to that in Philippines?
Your answer should be compact. 0.93. What is the ratio of the Emissions (1000 metric ton of CO2 equivalent) in 2000 in Paraguay to that in Philippines?
Give a very brief answer. 0.69. What is the ratio of the Emissions (1000 metric ton of CO2 equivalent) of 2005 in Paraguay to that in Philippines?
Keep it short and to the point. 0.78. What is the ratio of the Emissions (1000 metric ton of CO2 equivalent) of 2008 in Paraguay to that in Philippines?
Your response must be concise. 0.68. What is the ratio of the Emissions (1000 metric ton of CO2 equivalent) of 1990 in Paraguay to that in Poland?
Offer a terse response. 0.35. What is the ratio of the Emissions (1000 metric ton of CO2 equivalent) of 2000 in Paraguay to that in Poland?
Offer a terse response. 0.36. What is the ratio of the Emissions (1000 metric ton of CO2 equivalent) in 2005 in Paraguay to that in Poland?
Give a very brief answer. 0.42. What is the ratio of the Emissions (1000 metric ton of CO2 equivalent) of 2008 in Paraguay to that in Poland?
Offer a very short reply. 0.4. What is the ratio of the Emissions (1000 metric ton of CO2 equivalent) in 1990 in Peru to that in Philippines?
Ensure brevity in your answer.  0.55. What is the ratio of the Emissions (1000 metric ton of CO2 equivalent) in 2000 in Peru to that in Philippines?
Provide a short and direct response. 0.66. What is the ratio of the Emissions (1000 metric ton of CO2 equivalent) of 2005 in Peru to that in Philippines?
Make the answer very short. 0.65. What is the ratio of the Emissions (1000 metric ton of CO2 equivalent) of 2008 in Peru to that in Philippines?
Ensure brevity in your answer.  0.64. What is the ratio of the Emissions (1000 metric ton of CO2 equivalent) of 1990 in Peru to that in Poland?
Give a very brief answer. 0.21. What is the ratio of the Emissions (1000 metric ton of CO2 equivalent) in 2000 in Peru to that in Poland?
Provide a short and direct response. 0.34. What is the ratio of the Emissions (1000 metric ton of CO2 equivalent) of 2005 in Peru to that in Poland?
Make the answer very short. 0.35. What is the ratio of the Emissions (1000 metric ton of CO2 equivalent) in 2008 in Peru to that in Poland?
Your response must be concise. 0.37. What is the ratio of the Emissions (1000 metric ton of CO2 equivalent) of 1990 in Philippines to that in Poland?
Offer a very short reply. 0.37. What is the ratio of the Emissions (1000 metric ton of CO2 equivalent) in 2000 in Philippines to that in Poland?
Your answer should be compact. 0.52. What is the ratio of the Emissions (1000 metric ton of CO2 equivalent) in 2005 in Philippines to that in Poland?
Give a very brief answer. 0.54. What is the ratio of the Emissions (1000 metric ton of CO2 equivalent) in 2008 in Philippines to that in Poland?
Ensure brevity in your answer.  0.58. What is the difference between the highest and the second highest Emissions (1000 metric ton of CO2 equivalent) in 1990?
Your response must be concise. 5322.5. What is the difference between the highest and the second highest Emissions (1000 metric ton of CO2 equivalent) of 2000?
Your response must be concise. 821. What is the difference between the highest and the second highest Emissions (1000 metric ton of CO2 equivalent) in 2005?
Give a very brief answer. 2494.4. What is the difference between the highest and the second highest Emissions (1000 metric ton of CO2 equivalent) of 2008?
Your answer should be compact. 4741.7. What is the difference between the highest and the lowest Emissions (1000 metric ton of CO2 equivalent) of 1990?
Give a very brief answer. 1.81e+04. What is the difference between the highest and the lowest Emissions (1000 metric ton of CO2 equivalent) in 2000?
Your answer should be compact. 1.69e+04. What is the difference between the highest and the lowest Emissions (1000 metric ton of CO2 equivalent) of 2005?
Provide a short and direct response. 1.89e+04. What is the difference between the highest and the lowest Emissions (1000 metric ton of CO2 equivalent) of 2008?
Provide a short and direct response. 2.03e+04. 